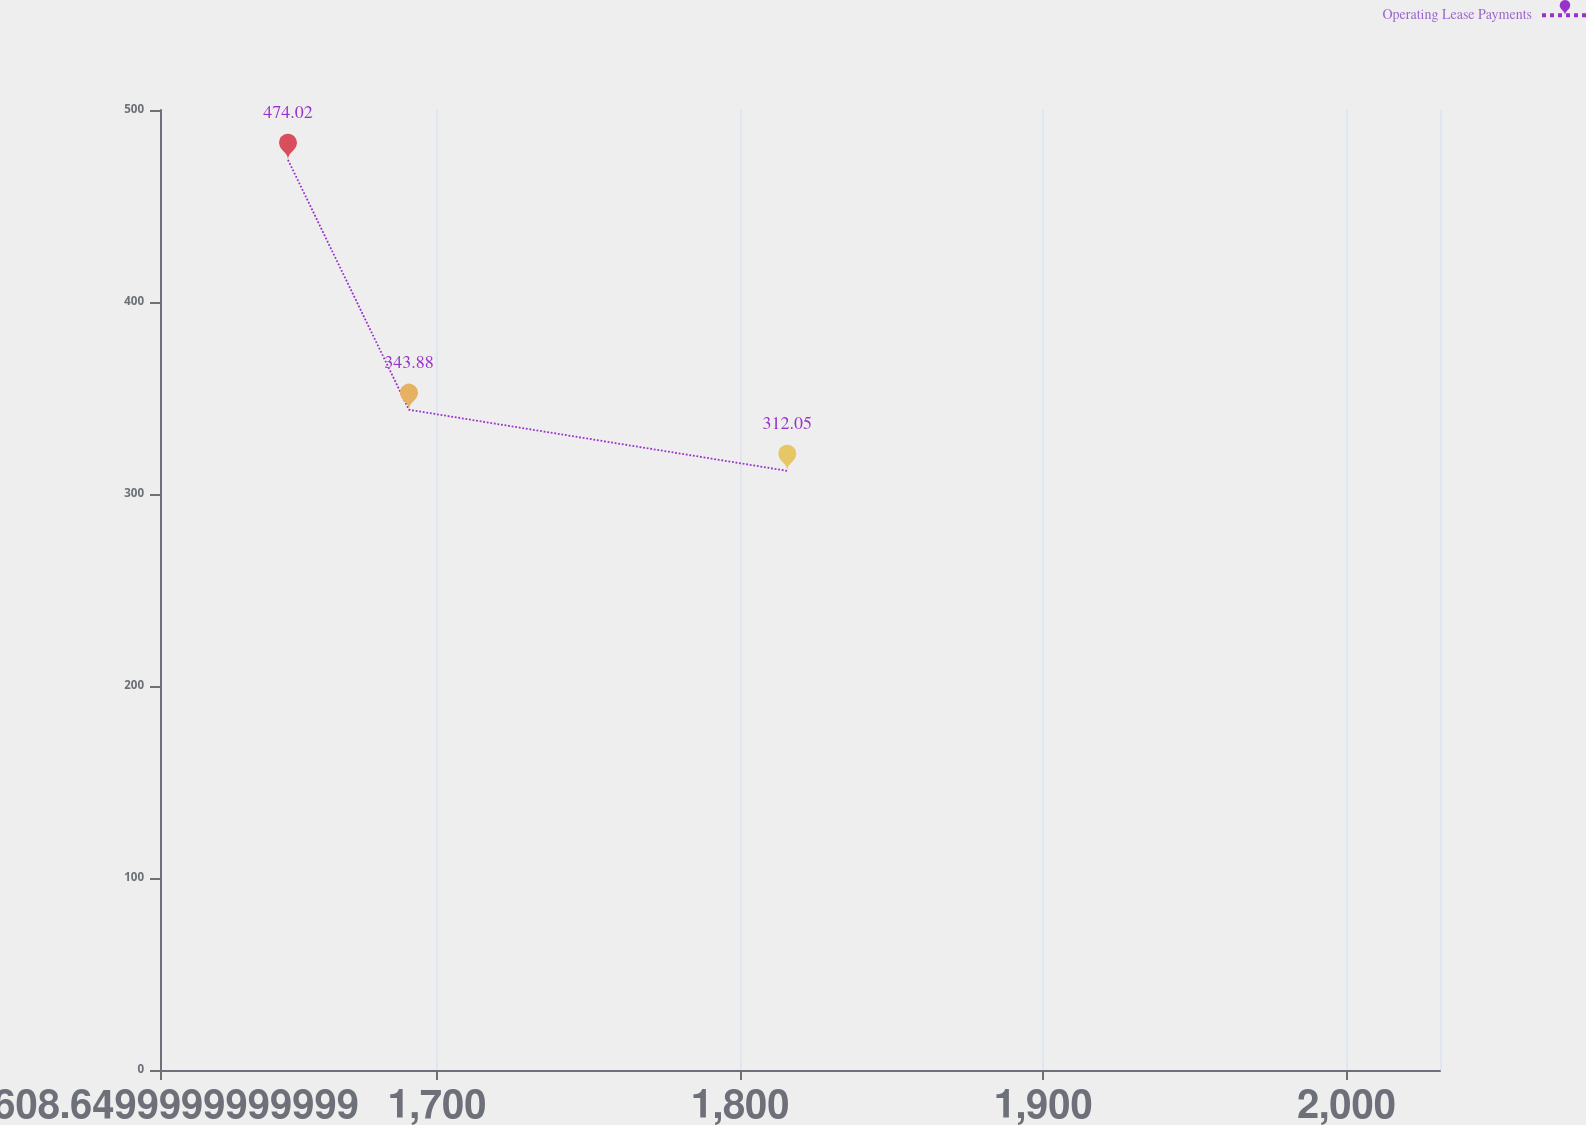Convert chart to OTSL. <chart><loc_0><loc_0><loc_500><loc_500><line_chart><ecel><fcel>Operating Lease Payments<nl><fcel>1650.87<fcel>474.02<nl><fcel>1690.78<fcel>343.88<nl><fcel>1815.56<fcel>312.05<nl><fcel>2033.16<fcel>223.12<nl><fcel>2073.07<fcel>155.72<nl></chart> 